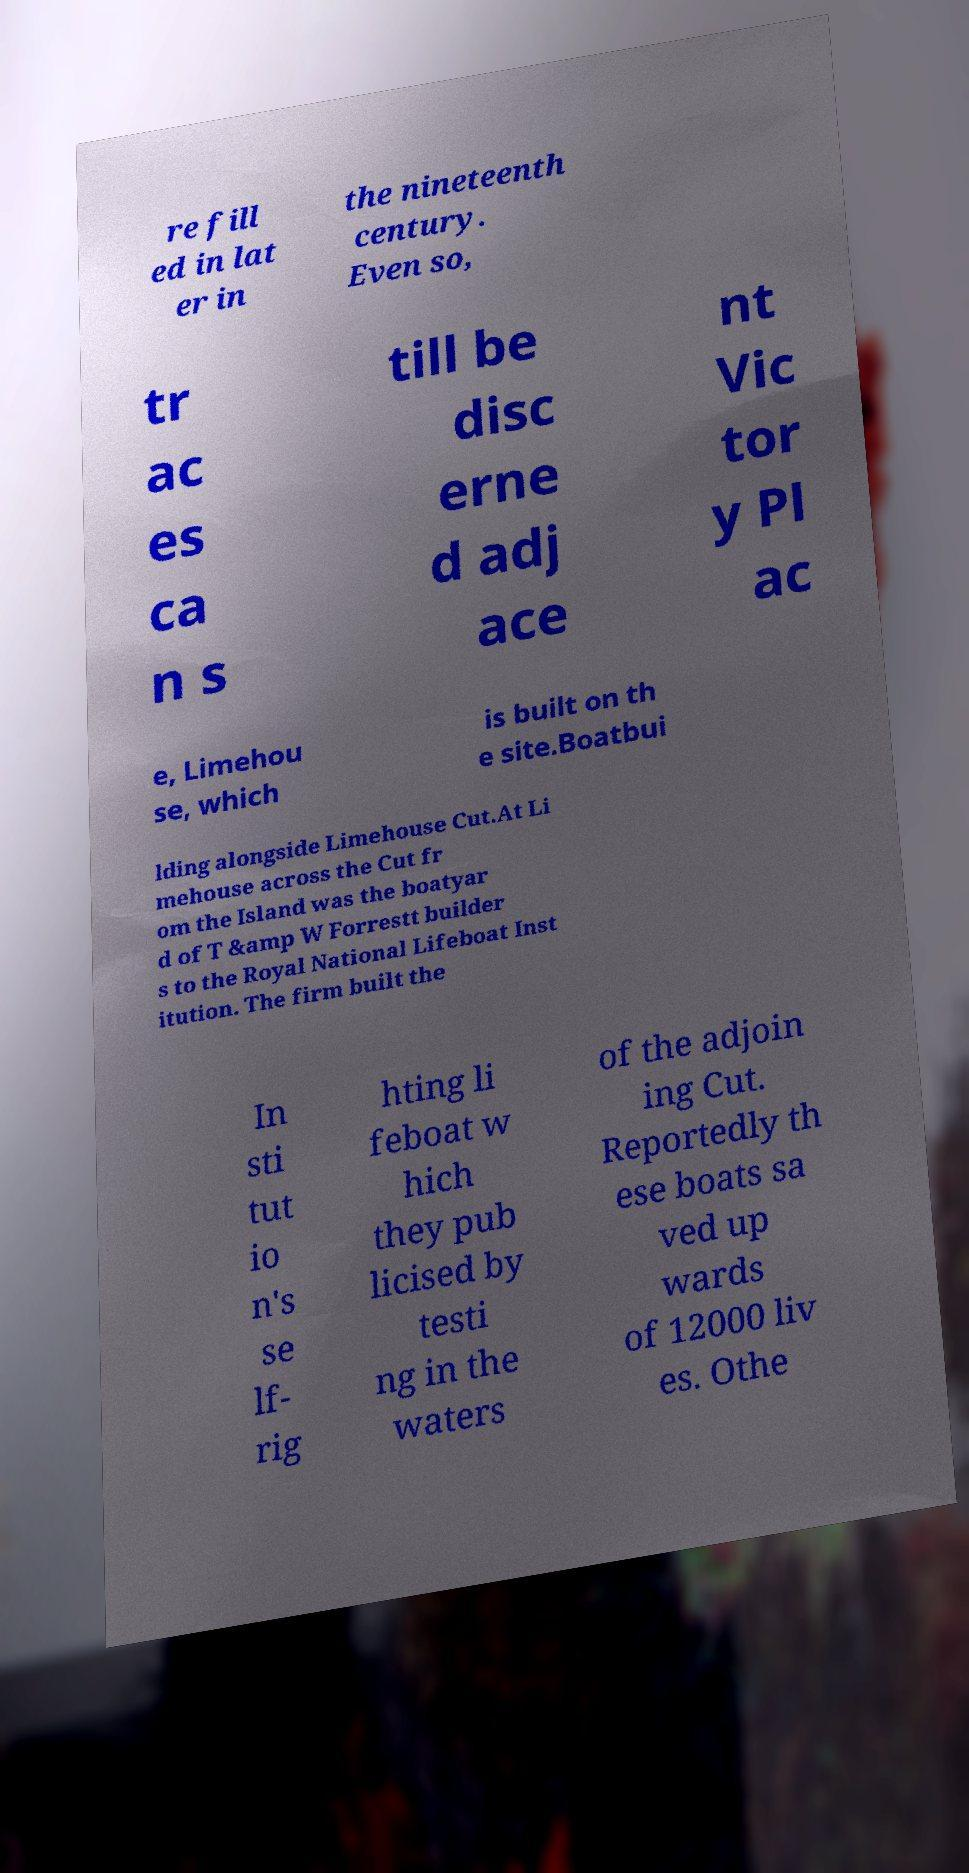Please identify and transcribe the text found in this image. re fill ed in lat er in the nineteenth century. Even so, tr ac es ca n s till be disc erne d adj ace nt Vic tor y Pl ac e, Limehou se, which is built on th e site.Boatbui lding alongside Limehouse Cut.At Li mehouse across the Cut fr om the Island was the boatyar d of T &amp W Forrestt builder s to the Royal National Lifeboat Inst itution. The firm built the In sti tut io n's se lf- rig hting li feboat w hich they pub licised by testi ng in the waters of the adjoin ing Cut. Reportedly th ese boats sa ved up wards of 12000 liv es. Othe 